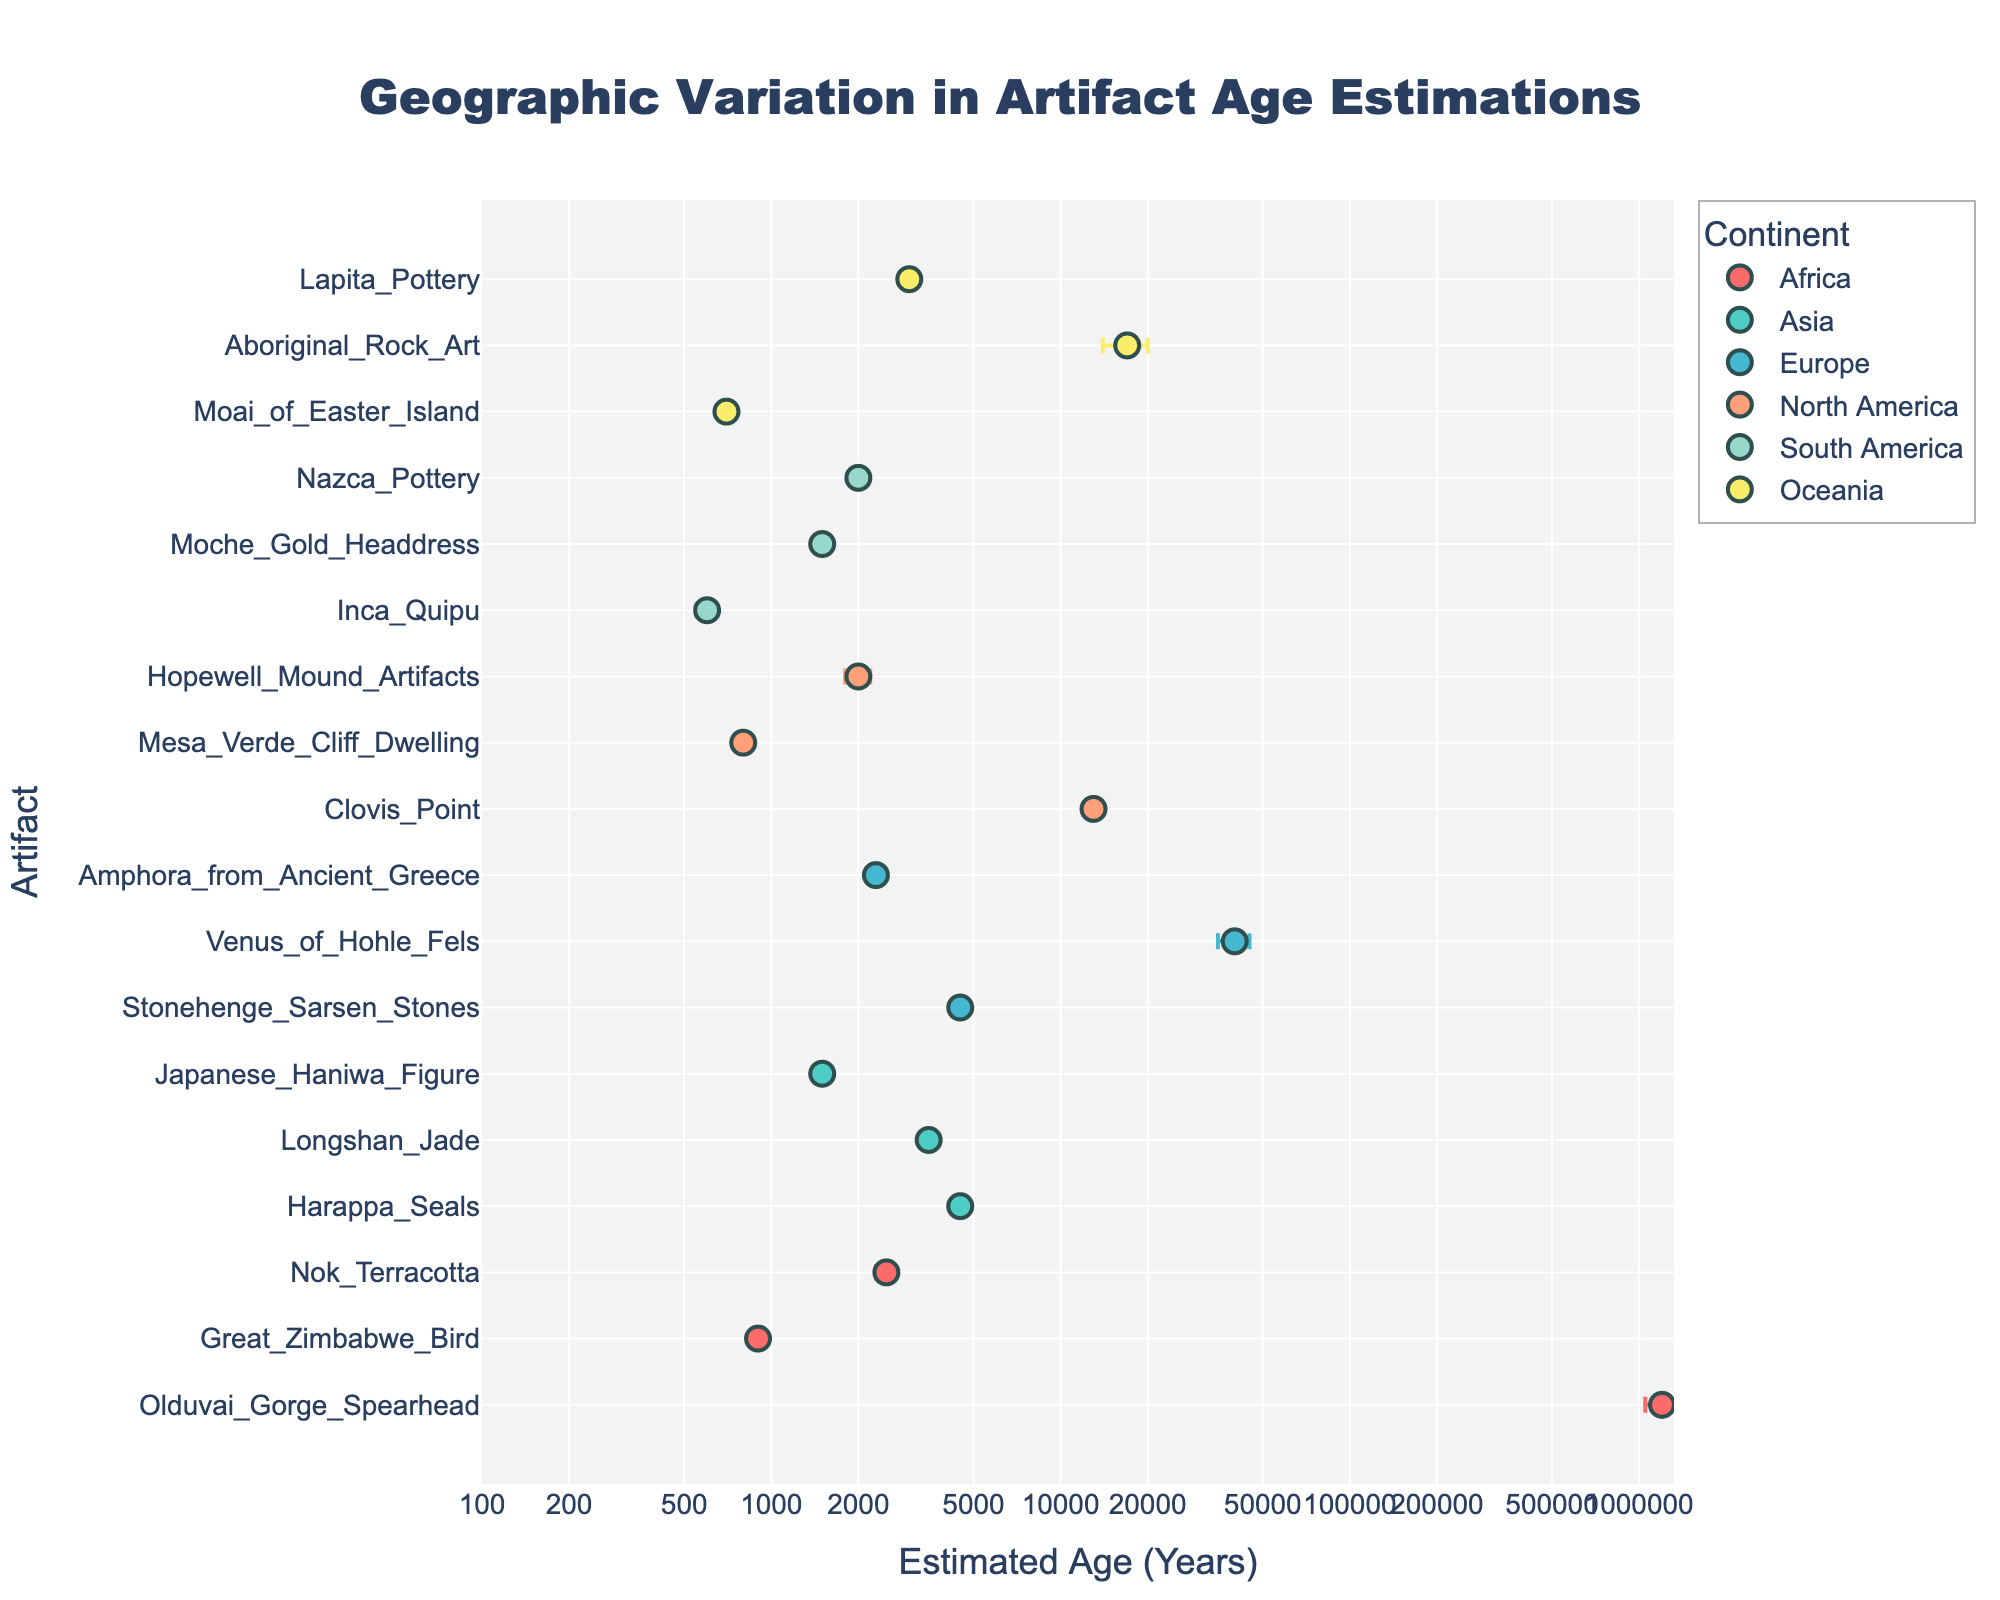What is the title of the plot? The title of the plot is usually placed at the top and is prominently displayed in larger font size compared to other text in the figure.
Answer: Geographic Variation in Artifact Age Estimations Which axis represents the estimated age and in what units? The x-axis of the scatter plot indicates the estimated ages of artifacts, and the units are in years.
Answer: x-axis, years Which continent has the artifact with the highest estimated age? The artifact with the highest estimated age appears visually furthest to the right on the x-axis. In this case, "Venus of Hohle Fels" from Europe has the highest estimated age.
Answer: Europe How many artifacts are represented for the continent of Africa? Each unique point (artifact) within the group labeled by color for the continent of Africa can be counted to determine this. There are three data points plotted for Africa.
Answer: Three Which artifact has the largest error bar? The size of the error bar for each artifact can be visually compared. "Aboriginal Rock Art" from Oceania has the largest error bar.
Answer: Aboriginal Rock Art Which two continents have artifacts with the closest estimated ages near 4500 years? By looking around 4500 years on the x-axis and observing the artifacts from different continents, both Asia (Harappa Seals) and Europe (Stonehenge Sarsen Stones) have artifacts near this estimated age.
Answer: Asia and Europe What is the difference in the estimated age between the "Hopewell Mound Artifacts" and the "Mesa Verde Cliff Dwelling"? Locate these artifacts on the y-axis and read their tied x-axis values, then subtract the smaller from the larger value. The Hopewell Mound Artifacts are 2000 years, and the Mesa Verde Cliff Dwelling is 800 years old. The difference is 2000 - 800 = 1200 years.
Answer: 1200 years What's the approximate average estimated age of artifacts from South America? The artifacts from South America and their estimated ages are identified: Inca Quipu (600 years), Moche Gold Headdress (1500 years), and Nazca Pottery (2000 years). Sum these values and divide by the number of artifacts: (600 + 1500 + 2000) / 3 ≈ 1400 years.
Answer: Approximately 1400 years Which continent has the smallest average error bar? Calculate the average error bar for each continent and then compare these averages. For Africa: (150000 + 50 + 200) / 3 = 50083.33, for Asia: (300 + 250 + 100) / 3 = 216.67, for Europe: (200 + 5000 + 100) / 3 = 1766.67, for North America: (1000 + 50 + 200) / 3 = 416.67, for South America: (50 + 100 + 150) / 3 = 100, for Oceania: (50 + 3000 + 200) / 3 = 1083.33. Thus, the smallest average error bar is for South America.
Answer: South America 